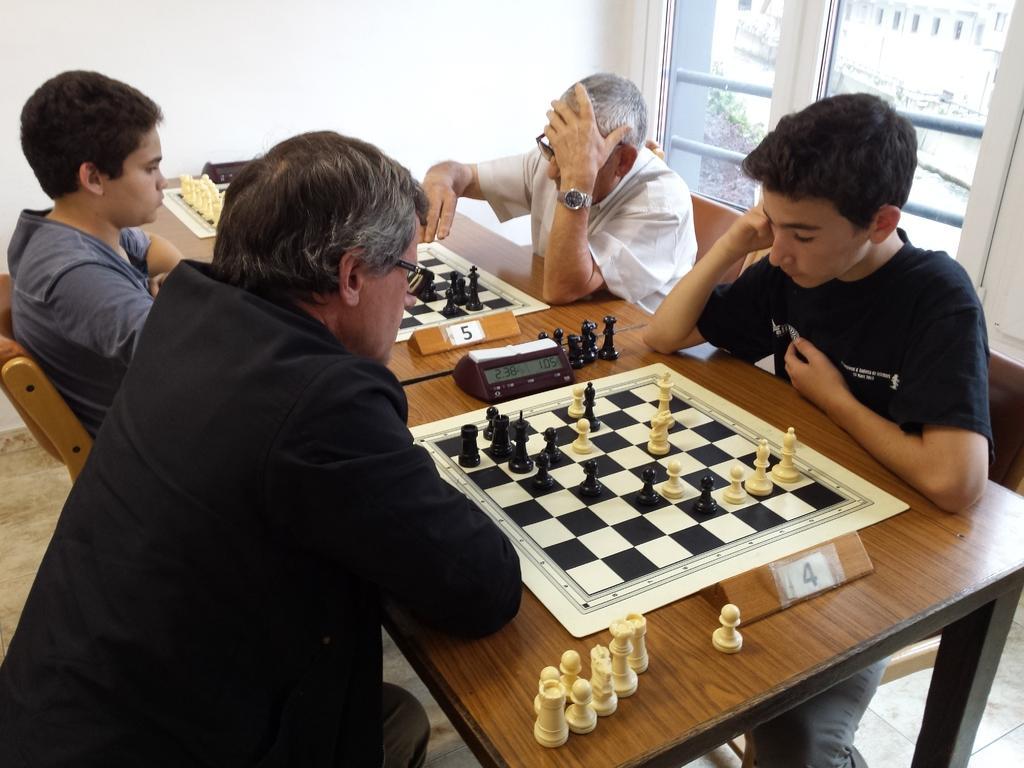Describe this image in one or two sentences. In the picture I can see four people are sitting on chairs in front of a table. On the table I can see chess boards and other objects on it. On the right side I can see a window and white color wall. 